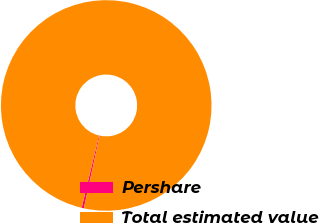<chart> <loc_0><loc_0><loc_500><loc_500><pie_chart><fcel>Pershare<fcel>Total estimated value<nl><fcel>0.34%<fcel>99.66%<nl></chart> 